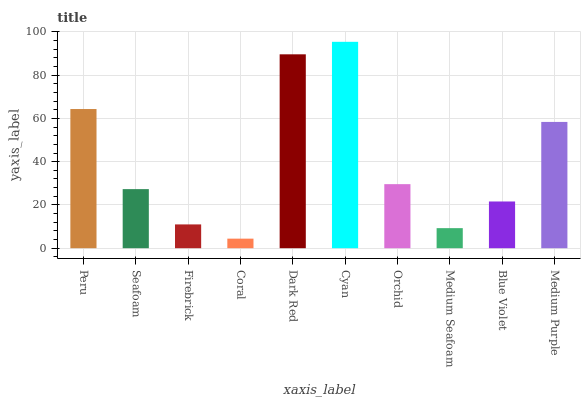Is Coral the minimum?
Answer yes or no. Yes. Is Cyan the maximum?
Answer yes or no. Yes. Is Seafoam the minimum?
Answer yes or no. No. Is Seafoam the maximum?
Answer yes or no. No. Is Peru greater than Seafoam?
Answer yes or no. Yes. Is Seafoam less than Peru?
Answer yes or no. Yes. Is Seafoam greater than Peru?
Answer yes or no. No. Is Peru less than Seafoam?
Answer yes or no. No. Is Orchid the high median?
Answer yes or no. Yes. Is Seafoam the low median?
Answer yes or no. Yes. Is Medium Purple the high median?
Answer yes or no. No. Is Firebrick the low median?
Answer yes or no. No. 